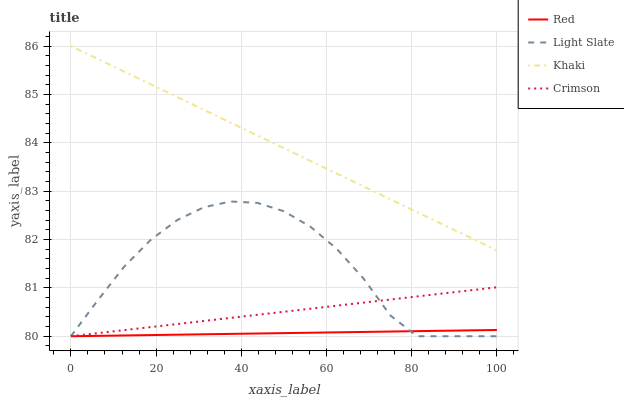Does Red have the minimum area under the curve?
Answer yes or no. Yes. Does Khaki have the maximum area under the curve?
Answer yes or no. Yes. Does Crimson have the minimum area under the curve?
Answer yes or no. No. Does Crimson have the maximum area under the curve?
Answer yes or no. No. Is Khaki the smoothest?
Answer yes or no. Yes. Is Light Slate the roughest?
Answer yes or no. Yes. Is Crimson the smoothest?
Answer yes or no. No. Is Crimson the roughest?
Answer yes or no. No. Does Khaki have the lowest value?
Answer yes or no. No. Does Khaki have the highest value?
Answer yes or no. Yes. Does Crimson have the highest value?
Answer yes or no. No. Is Crimson less than Khaki?
Answer yes or no. Yes. Is Khaki greater than Red?
Answer yes or no. Yes. Does Crimson intersect Red?
Answer yes or no. Yes. Is Crimson less than Red?
Answer yes or no. No. Is Crimson greater than Red?
Answer yes or no. No. Does Crimson intersect Khaki?
Answer yes or no. No. 